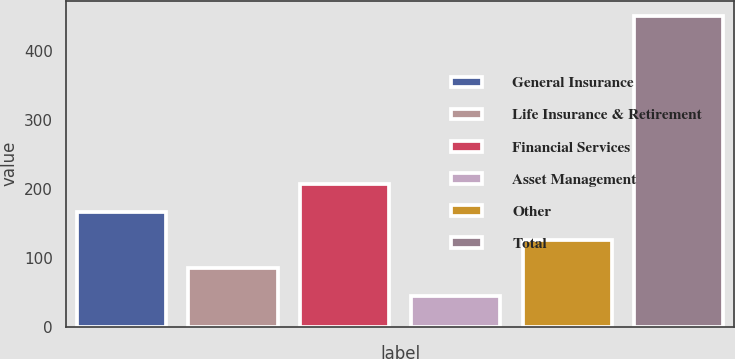Convert chart to OTSL. <chart><loc_0><loc_0><loc_500><loc_500><bar_chart><fcel>General Insurance<fcel>Life Insurance & Retirement<fcel>Financial Services<fcel>Asset Management<fcel>Other<fcel>Total<nl><fcel>166.8<fcel>85.6<fcel>207.4<fcel>45<fcel>126.2<fcel>451<nl></chart> 